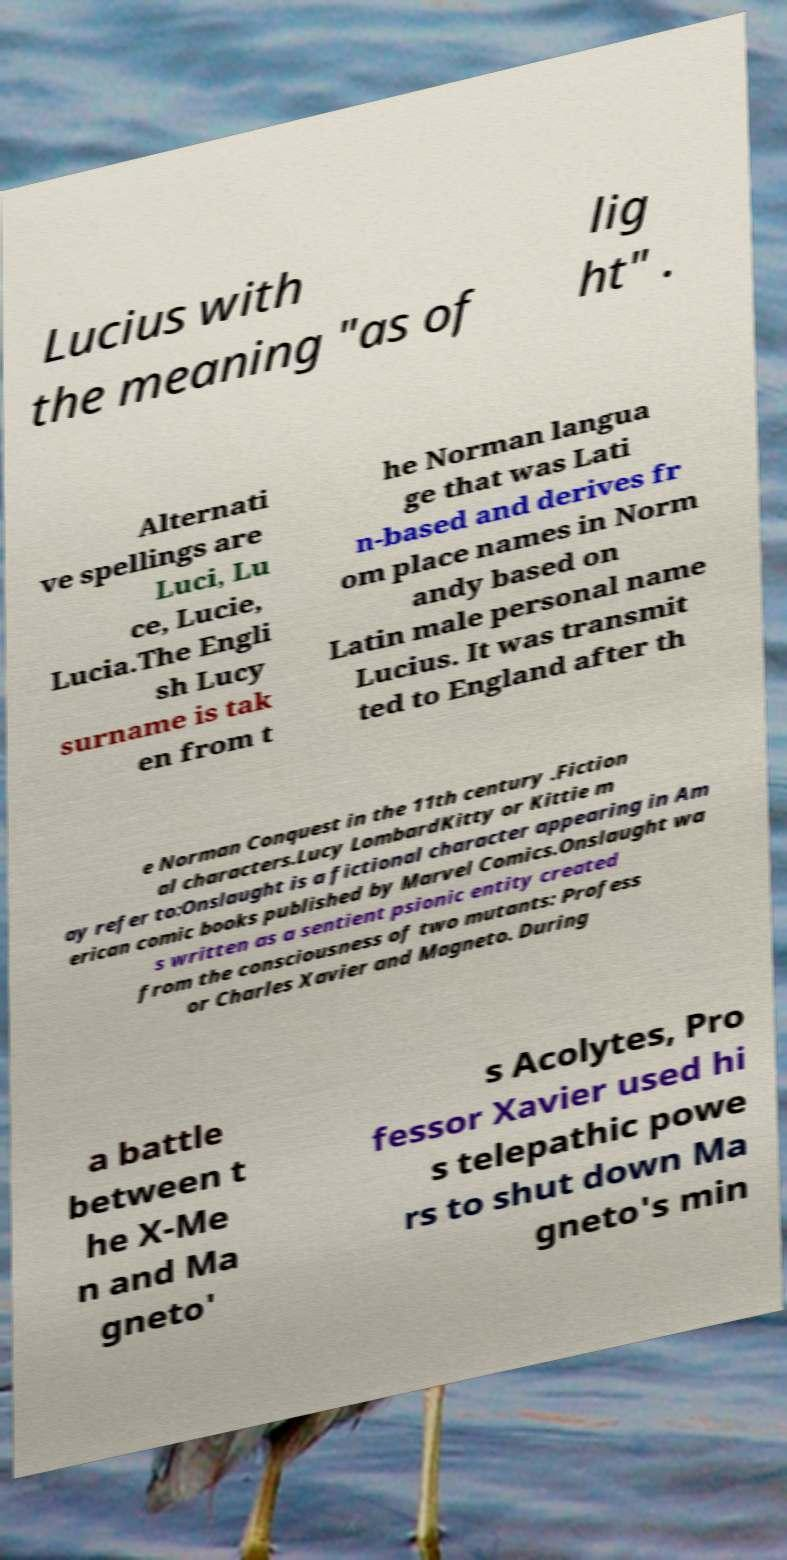There's text embedded in this image that I need extracted. Can you transcribe it verbatim? Lucius with the meaning "as of lig ht" . Alternati ve spellings are Luci, Lu ce, Lucie, Lucia.The Engli sh Lucy surname is tak en from t he Norman langua ge that was Lati n-based and derives fr om place names in Norm andy based on Latin male personal name Lucius. It was transmit ted to England after th e Norman Conquest in the 11th century .Fiction al characters.Lucy LombardKitty or Kittie m ay refer to:Onslaught is a fictional character appearing in Am erican comic books published by Marvel Comics.Onslaught wa s written as a sentient psionic entity created from the consciousness of two mutants: Profess or Charles Xavier and Magneto. During a battle between t he X-Me n and Ma gneto' s Acolytes, Pro fessor Xavier used hi s telepathic powe rs to shut down Ma gneto's min 